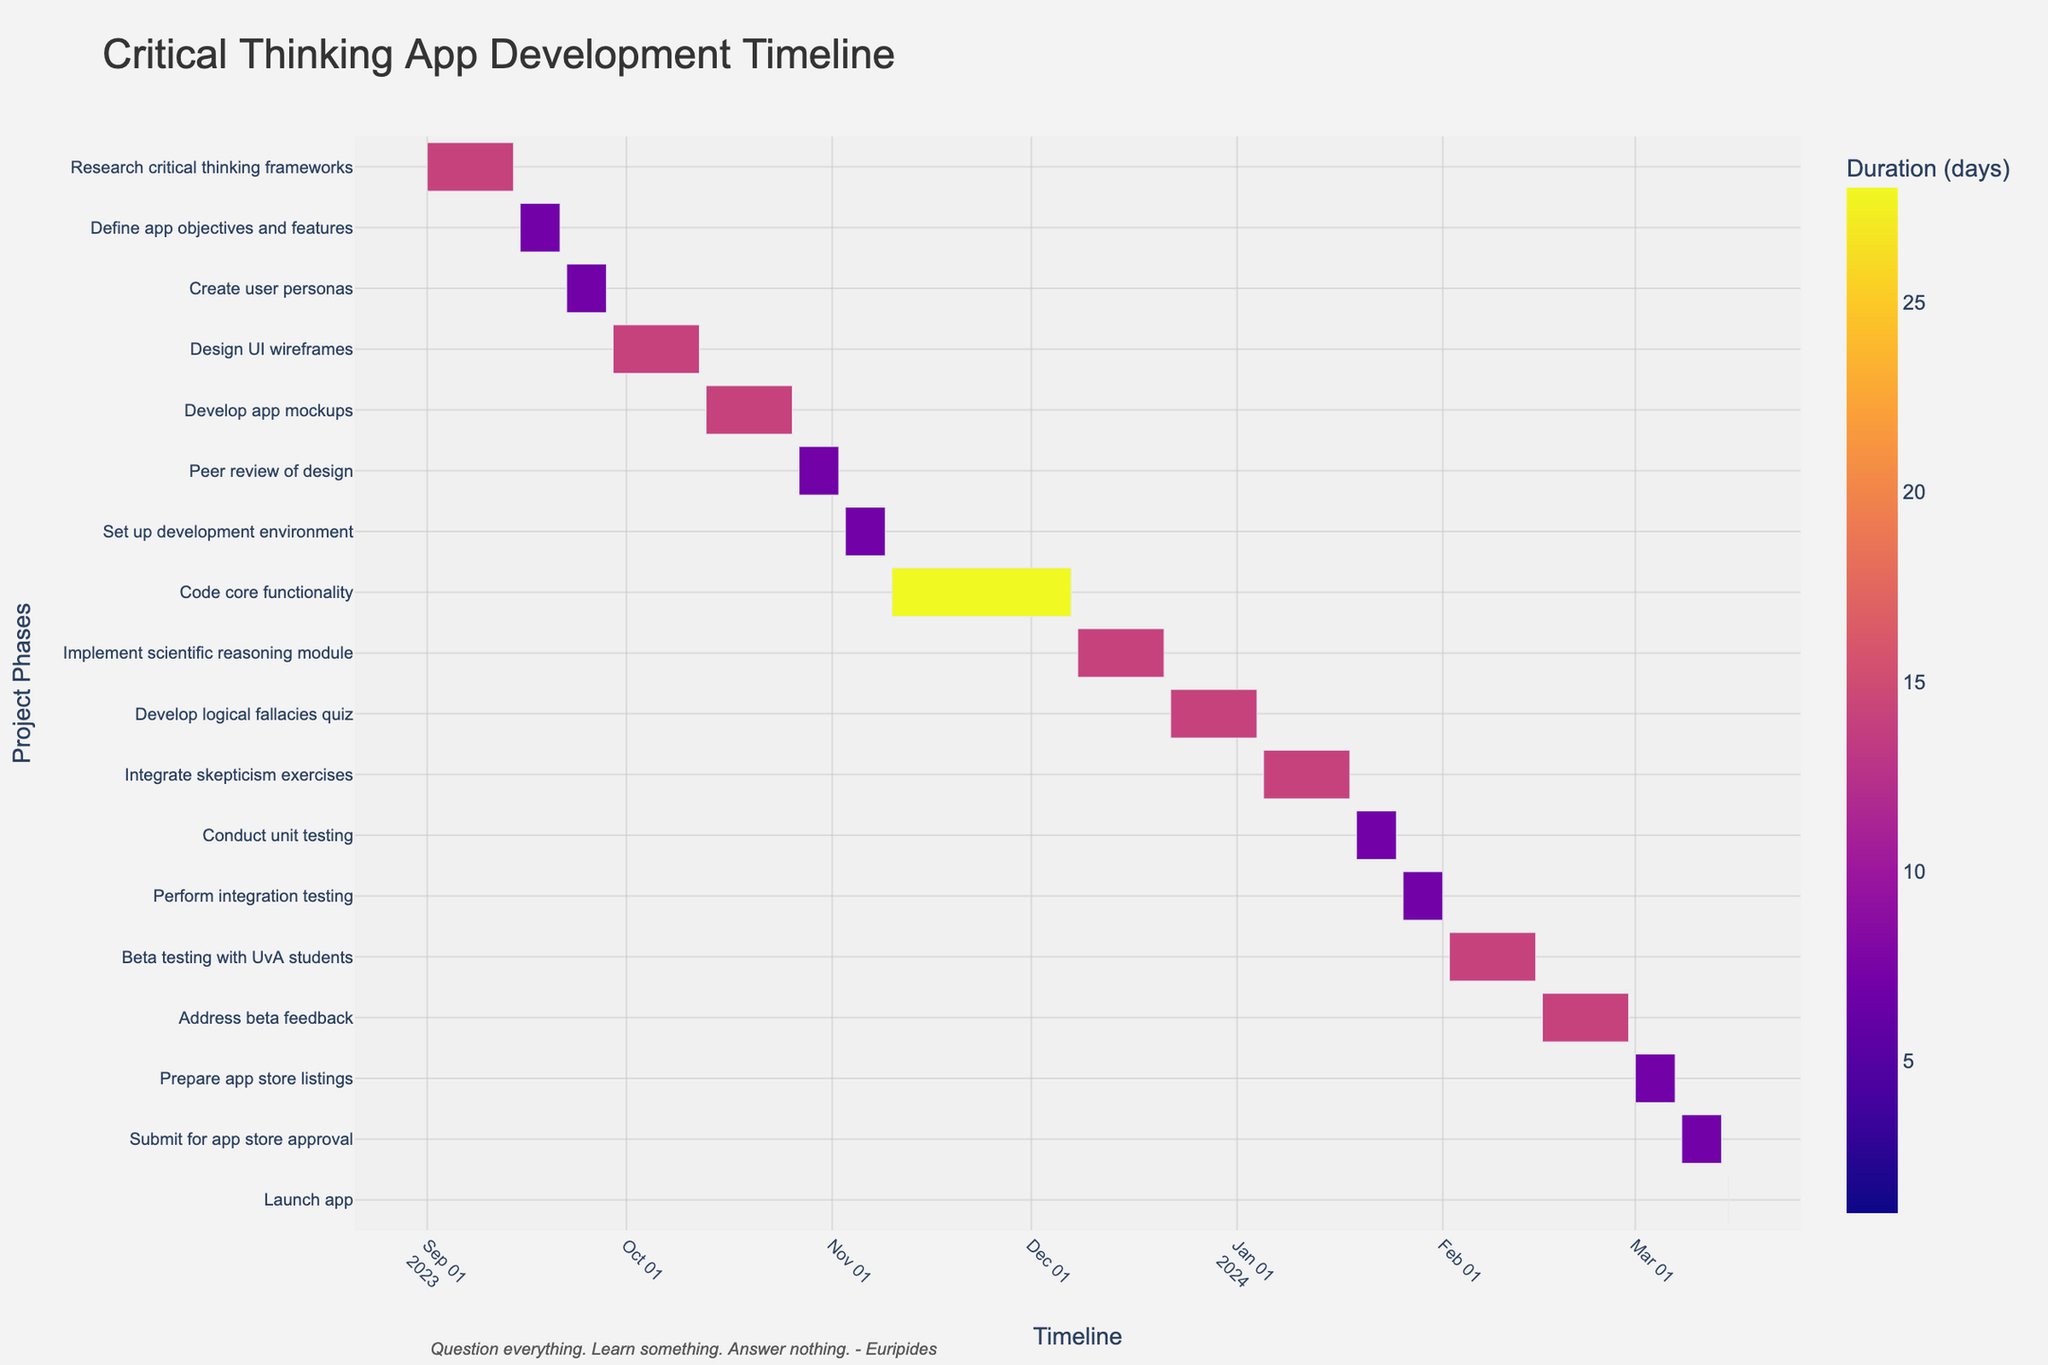How many phases are detailed in the app development timeline? Count the number of different project phases listed on the Y-axis.
Answer: 18 What is the longest single task in the development process? Identify the task with the longest duration (shown by the length of the bar).
Answer: Code core functionality Which task has the shortest duration? Look for the task with the shortest bar and confirm its duration.
Answer: Launch app When does the design phase end? Check the end date of the last task within the design phase, which includes Design UI wireframes, Develop app mockups, and Peer review of design.
Answer: November 2, 2023 How many days are allocated for Beta testing with UvA students? Identify the bar corresponding to Beta testing and read the duration value.
Answer: 14 days Which task immediately follows "Develop logical fallacies quiz"? Look at the sequence of tasks and find the one that starts right after the end of "Develop logical fallacies quiz".
Answer: Integrate skepticism exercises What is the combined duration of coding and testing phases in days? Add the durations of all tasks within the coding phase (Code core functionality, Implement scientific reasoning module, Develop logical fallacies quiz, Integrate skepticism exercises) and the testing phase (Conduct unit testing, Perform integration testing, Beta testing with UvA students).
Answer: 84 days Which task is a prerequisite for "Submit for app store approval"? Identify the task that ends just before "Submit for app store approval" begins.
Answer: Prepare app store listings How does the duration of "Research critical thinking frameworks" compare with "Implement scientific reasoning module"? Compare the duration of both tasks based on their lengths as shown by the bars.
Answer: Research critical thinking frameworks is longer Do any tasks overlap in December 2023? Observe the timeline to see if any bars (tasks) are running concurrently in December 2023.
Answer: Yes (Implement scientific reasoning module and Develop logical fallacies quiz) 